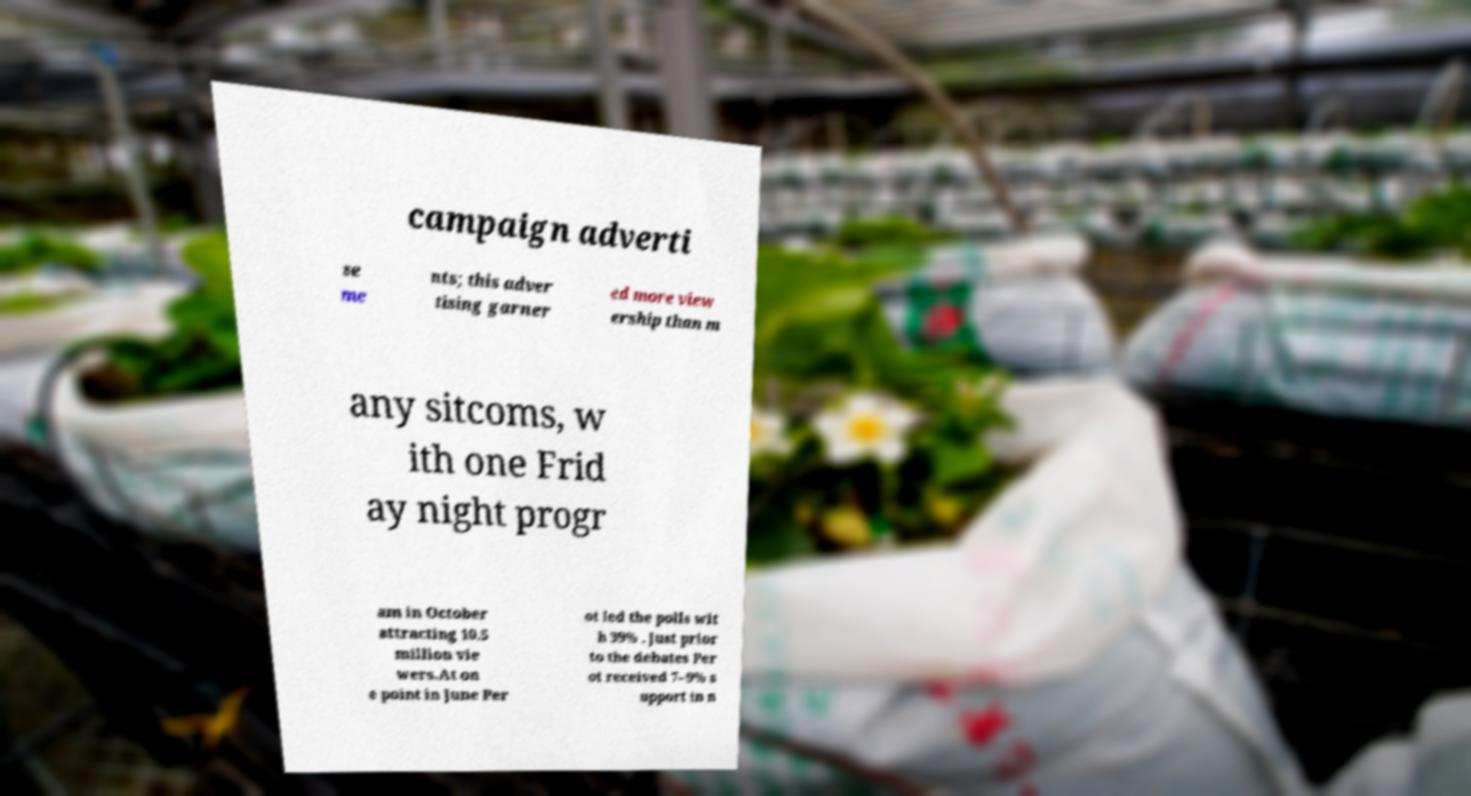What messages or text are displayed in this image? I need them in a readable, typed format. campaign adverti se me nts; this adver tising garner ed more view ership than m any sitcoms, w ith one Frid ay night progr am in October attracting 10.5 million vie wers.At on e point in June Per ot led the polls wit h 39% . Just prior to the debates Per ot received 7–9% s upport in n 